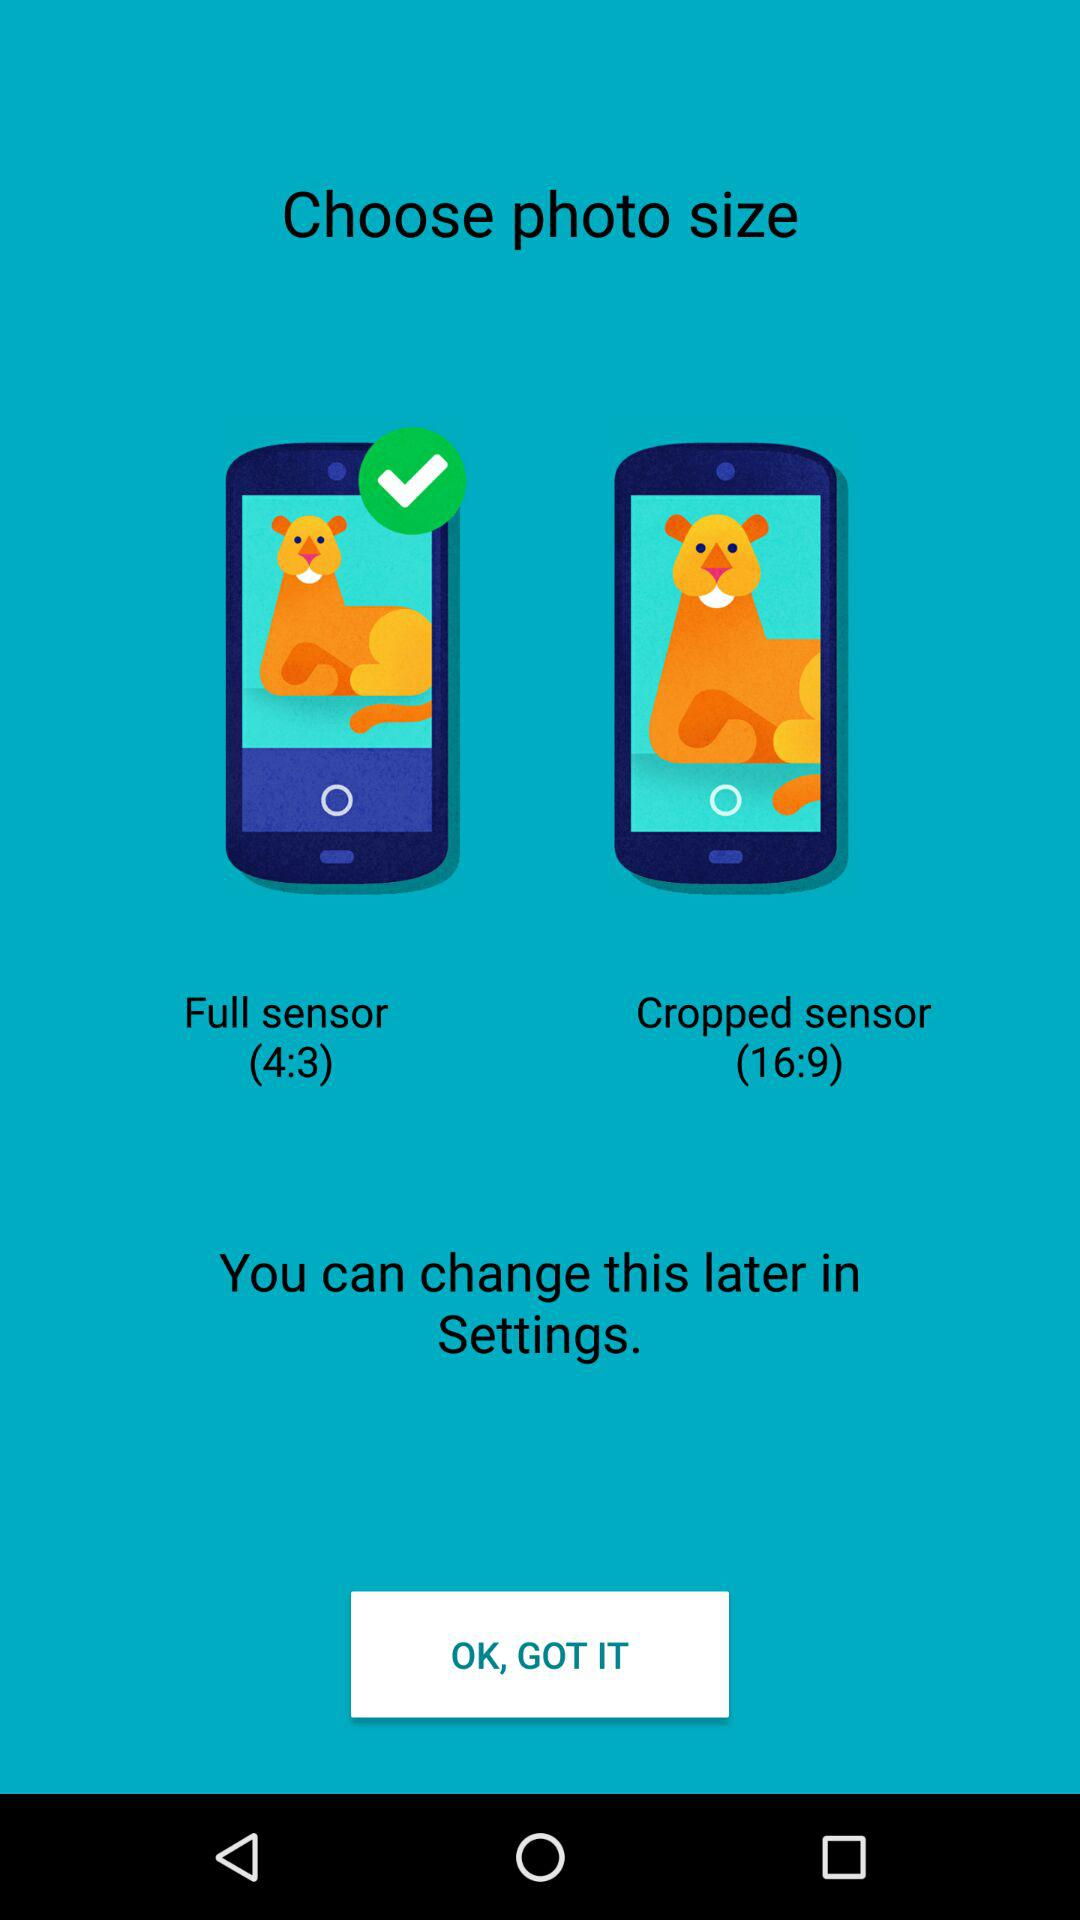How many photo sizes are there?
Answer the question using a single word or phrase. 2 